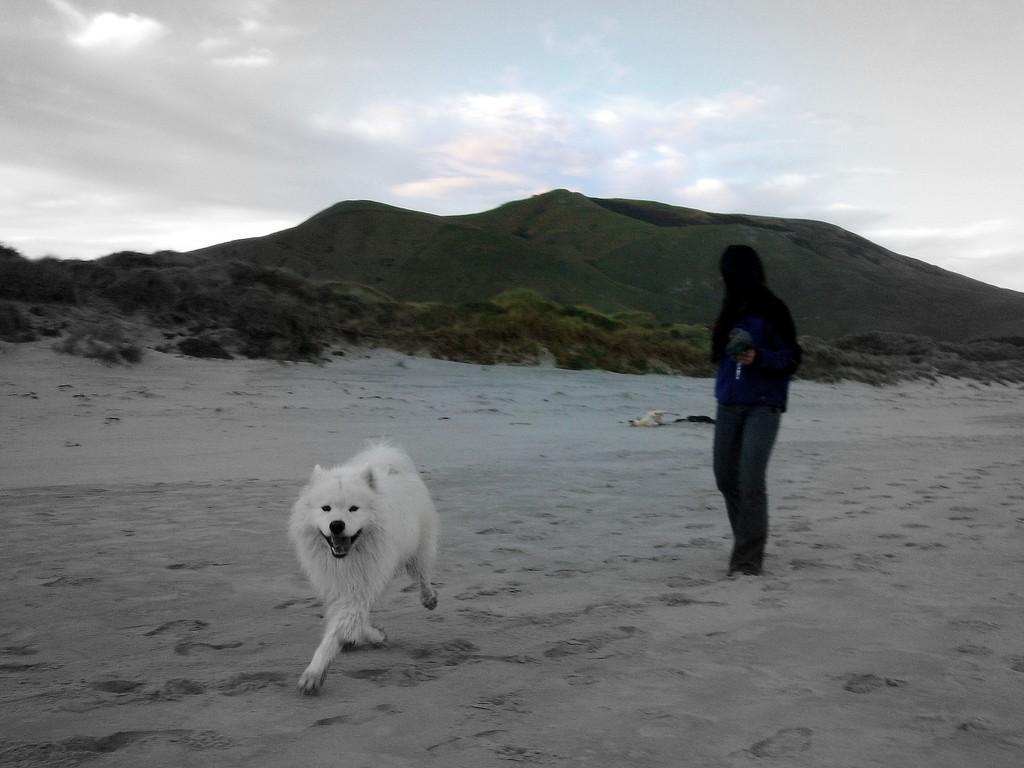In one or two sentences, can you explain what this image depicts? A white dog is running. A person is standing. There are plants and mountains at the back. 